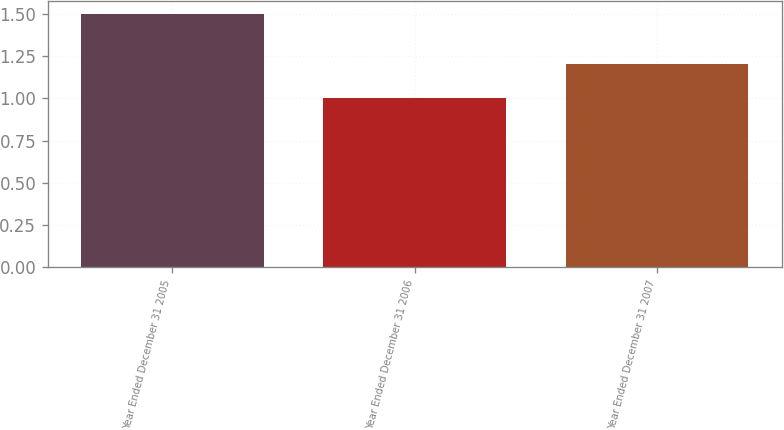Convert chart. <chart><loc_0><loc_0><loc_500><loc_500><bar_chart><fcel>Year Ended December 31 2005<fcel>Year Ended December 31 2006<fcel>Year Ended December 31 2007<nl><fcel>1.5<fcel>1<fcel>1.2<nl></chart> 